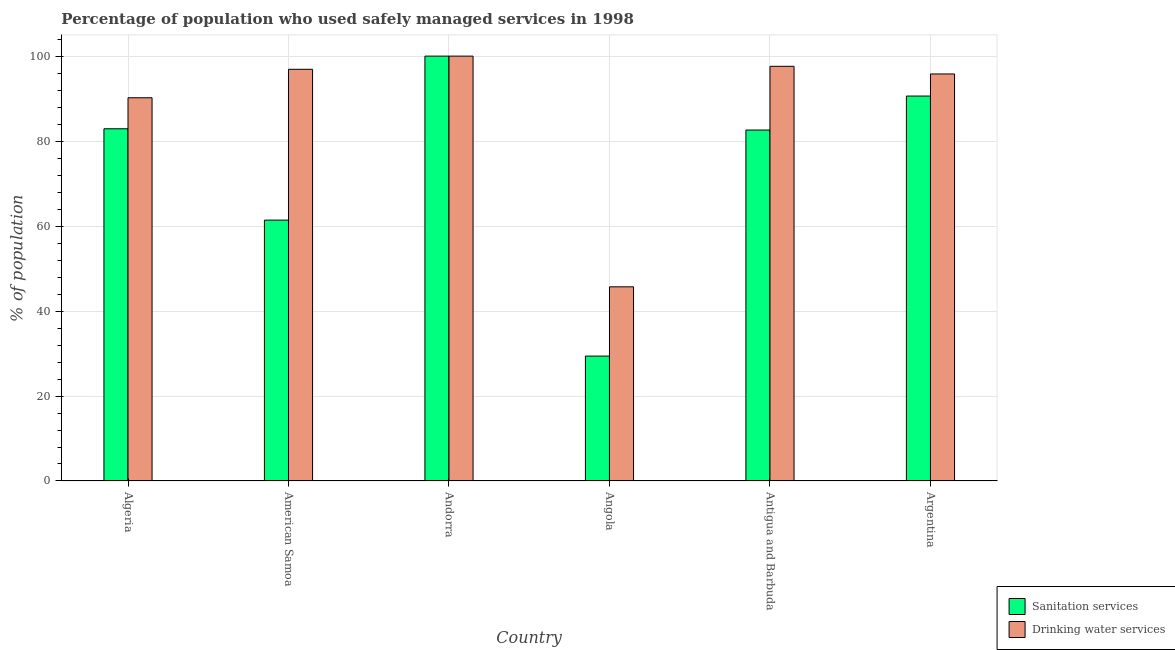Are the number of bars on each tick of the X-axis equal?
Offer a very short reply. Yes. How many bars are there on the 1st tick from the left?
Ensure brevity in your answer.  2. How many bars are there on the 5th tick from the right?
Keep it short and to the point. 2. What is the label of the 1st group of bars from the left?
Your response must be concise. Algeria. In how many cases, is the number of bars for a given country not equal to the number of legend labels?
Ensure brevity in your answer.  0. What is the percentage of population who used drinking water services in Angola?
Provide a succinct answer. 45.7. Across all countries, what is the maximum percentage of population who used drinking water services?
Give a very brief answer. 100. Across all countries, what is the minimum percentage of population who used drinking water services?
Make the answer very short. 45.7. In which country was the percentage of population who used sanitation services maximum?
Give a very brief answer. Andorra. In which country was the percentage of population who used drinking water services minimum?
Your answer should be very brief. Angola. What is the total percentage of population who used sanitation services in the graph?
Your response must be concise. 446.9. What is the difference between the percentage of population who used sanitation services in Algeria and that in American Samoa?
Your answer should be very brief. 21.5. What is the difference between the percentage of population who used sanitation services in Antigua and Barbuda and the percentage of population who used drinking water services in Andorra?
Provide a succinct answer. -17.4. What is the average percentage of population who used sanitation services per country?
Provide a short and direct response. 74.48. What is the difference between the percentage of population who used sanitation services and percentage of population who used drinking water services in Angola?
Offer a terse response. -16.3. What is the ratio of the percentage of population who used drinking water services in American Samoa to that in Antigua and Barbuda?
Ensure brevity in your answer.  0.99. Is the percentage of population who used drinking water services in Antigua and Barbuda less than that in Argentina?
Your answer should be very brief. No. What is the difference between the highest and the second highest percentage of population who used sanitation services?
Offer a terse response. 9.4. What is the difference between the highest and the lowest percentage of population who used drinking water services?
Provide a succinct answer. 54.3. In how many countries, is the percentage of population who used drinking water services greater than the average percentage of population who used drinking water services taken over all countries?
Ensure brevity in your answer.  5. Is the sum of the percentage of population who used drinking water services in Antigua and Barbuda and Argentina greater than the maximum percentage of population who used sanitation services across all countries?
Your answer should be very brief. Yes. What does the 1st bar from the left in Andorra represents?
Your answer should be very brief. Sanitation services. What does the 2nd bar from the right in American Samoa represents?
Your response must be concise. Sanitation services. Are all the bars in the graph horizontal?
Offer a very short reply. No. How many countries are there in the graph?
Ensure brevity in your answer.  6. What is the difference between two consecutive major ticks on the Y-axis?
Your answer should be compact. 20. How many legend labels are there?
Offer a very short reply. 2. How are the legend labels stacked?
Offer a terse response. Vertical. What is the title of the graph?
Provide a succinct answer. Percentage of population who used safely managed services in 1998. What is the label or title of the Y-axis?
Offer a terse response. % of population. What is the % of population of Sanitation services in Algeria?
Make the answer very short. 82.9. What is the % of population in Drinking water services in Algeria?
Your response must be concise. 90.2. What is the % of population of Sanitation services in American Samoa?
Your response must be concise. 61.4. What is the % of population of Drinking water services in American Samoa?
Offer a terse response. 96.9. What is the % of population in Sanitation services in Angola?
Your response must be concise. 29.4. What is the % of population of Drinking water services in Angola?
Your answer should be very brief. 45.7. What is the % of population of Sanitation services in Antigua and Barbuda?
Make the answer very short. 82.6. What is the % of population of Drinking water services in Antigua and Barbuda?
Keep it short and to the point. 97.6. What is the % of population of Sanitation services in Argentina?
Offer a very short reply. 90.6. What is the % of population of Drinking water services in Argentina?
Provide a short and direct response. 95.8. Across all countries, what is the maximum % of population in Drinking water services?
Keep it short and to the point. 100. Across all countries, what is the minimum % of population in Sanitation services?
Your answer should be very brief. 29.4. Across all countries, what is the minimum % of population in Drinking water services?
Give a very brief answer. 45.7. What is the total % of population in Sanitation services in the graph?
Give a very brief answer. 446.9. What is the total % of population in Drinking water services in the graph?
Keep it short and to the point. 526.2. What is the difference between the % of population of Sanitation services in Algeria and that in American Samoa?
Provide a succinct answer. 21.5. What is the difference between the % of population of Drinking water services in Algeria and that in American Samoa?
Make the answer very short. -6.7. What is the difference between the % of population of Sanitation services in Algeria and that in Andorra?
Keep it short and to the point. -17.1. What is the difference between the % of population of Drinking water services in Algeria and that in Andorra?
Your answer should be compact. -9.8. What is the difference between the % of population in Sanitation services in Algeria and that in Angola?
Your answer should be compact. 53.5. What is the difference between the % of population of Drinking water services in Algeria and that in Angola?
Provide a short and direct response. 44.5. What is the difference between the % of population of Sanitation services in Algeria and that in Antigua and Barbuda?
Provide a succinct answer. 0.3. What is the difference between the % of population in Sanitation services in American Samoa and that in Andorra?
Provide a short and direct response. -38.6. What is the difference between the % of population in Sanitation services in American Samoa and that in Angola?
Provide a succinct answer. 32. What is the difference between the % of population of Drinking water services in American Samoa and that in Angola?
Your answer should be very brief. 51.2. What is the difference between the % of population in Sanitation services in American Samoa and that in Antigua and Barbuda?
Give a very brief answer. -21.2. What is the difference between the % of population in Drinking water services in American Samoa and that in Antigua and Barbuda?
Your answer should be compact. -0.7. What is the difference between the % of population of Sanitation services in American Samoa and that in Argentina?
Ensure brevity in your answer.  -29.2. What is the difference between the % of population of Sanitation services in Andorra and that in Angola?
Your answer should be compact. 70.6. What is the difference between the % of population of Drinking water services in Andorra and that in Angola?
Provide a short and direct response. 54.3. What is the difference between the % of population of Drinking water services in Andorra and that in Antigua and Barbuda?
Provide a short and direct response. 2.4. What is the difference between the % of population in Sanitation services in Andorra and that in Argentina?
Keep it short and to the point. 9.4. What is the difference between the % of population of Sanitation services in Angola and that in Antigua and Barbuda?
Ensure brevity in your answer.  -53.2. What is the difference between the % of population of Drinking water services in Angola and that in Antigua and Barbuda?
Make the answer very short. -51.9. What is the difference between the % of population of Sanitation services in Angola and that in Argentina?
Keep it short and to the point. -61.2. What is the difference between the % of population of Drinking water services in Angola and that in Argentina?
Make the answer very short. -50.1. What is the difference between the % of population in Sanitation services in Antigua and Barbuda and that in Argentina?
Ensure brevity in your answer.  -8. What is the difference between the % of population in Sanitation services in Algeria and the % of population in Drinking water services in Andorra?
Offer a very short reply. -17.1. What is the difference between the % of population of Sanitation services in Algeria and the % of population of Drinking water services in Angola?
Ensure brevity in your answer.  37.2. What is the difference between the % of population of Sanitation services in Algeria and the % of population of Drinking water services in Antigua and Barbuda?
Your response must be concise. -14.7. What is the difference between the % of population of Sanitation services in Algeria and the % of population of Drinking water services in Argentina?
Give a very brief answer. -12.9. What is the difference between the % of population in Sanitation services in American Samoa and the % of population in Drinking water services in Andorra?
Keep it short and to the point. -38.6. What is the difference between the % of population of Sanitation services in American Samoa and the % of population of Drinking water services in Angola?
Offer a terse response. 15.7. What is the difference between the % of population of Sanitation services in American Samoa and the % of population of Drinking water services in Antigua and Barbuda?
Make the answer very short. -36.2. What is the difference between the % of population in Sanitation services in American Samoa and the % of population in Drinking water services in Argentina?
Make the answer very short. -34.4. What is the difference between the % of population in Sanitation services in Andorra and the % of population in Drinking water services in Angola?
Offer a terse response. 54.3. What is the difference between the % of population in Sanitation services in Andorra and the % of population in Drinking water services in Antigua and Barbuda?
Offer a very short reply. 2.4. What is the difference between the % of population of Sanitation services in Andorra and the % of population of Drinking water services in Argentina?
Your answer should be very brief. 4.2. What is the difference between the % of population in Sanitation services in Angola and the % of population in Drinking water services in Antigua and Barbuda?
Provide a succinct answer. -68.2. What is the difference between the % of population of Sanitation services in Angola and the % of population of Drinking water services in Argentina?
Your response must be concise. -66.4. What is the average % of population in Sanitation services per country?
Provide a succinct answer. 74.48. What is the average % of population of Drinking water services per country?
Your answer should be compact. 87.7. What is the difference between the % of population of Sanitation services and % of population of Drinking water services in Algeria?
Make the answer very short. -7.3. What is the difference between the % of population of Sanitation services and % of population of Drinking water services in American Samoa?
Your answer should be compact. -35.5. What is the difference between the % of population in Sanitation services and % of population in Drinking water services in Angola?
Ensure brevity in your answer.  -16.3. What is the difference between the % of population of Sanitation services and % of population of Drinking water services in Argentina?
Offer a terse response. -5.2. What is the ratio of the % of population in Sanitation services in Algeria to that in American Samoa?
Ensure brevity in your answer.  1.35. What is the ratio of the % of population of Drinking water services in Algeria to that in American Samoa?
Your answer should be very brief. 0.93. What is the ratio of the % of population in Sanitation services in Algeria to that in Andorra?
Your response must be concise. 0.83. What is the ratio of the % of population of Drinking water services in Algeria to that in Andorra?
Offer a terse response. 0.9. What is the ratio of the % of population of Sanitation services in Algeria to that in Angola?
Provide a succinct answer. 2.82. What is the ratio of the % of population of Drinking water services in Algeria to that in Angola?
Your answer should be compact. 1.97. What is the ratio of the % of population of Sanitation services in Algeria to that in Antigua and Barbuda?
Provide a succinct answer. 1. What is the ratio of the % of population of Drinking water services in Algeria to that in Antigua and Barbuda?
Give a very brief answer. 0.92. What is the ratio of the % of population of Sanitation services in Algeria to that in Argentina?
Keep it short and to the point. 0.92. What is the ratio of the % of population of Drinking water services in Algeria to that in Argentina?
Your answer should be very brief. 0.94. What is the ratio of the % of population in Sanitation services in American Samoa to that in Andorra?
Provide a succinct answer. 0.61. What is the ratio of the % of population in Drinking water services in American Samoa to that in Andorra?
Keep it short and to the point. 0.97. What is the ratio of the % of population in Sanitation services in American Samoa to that in Angola?
Your answer should be very brief. 2.09. What is the ratio of the % of population in Drinking water services in American Samoa to that in Angola?
Your answer should be very brief. 2.12. What is the ratio of the % of population in Sanitation services in American Samoa to that in Antigua and Barbuda?
Offer a terse response. 0.74. What is the ratio of the % of population of Sanitation services in American Samoa to that in Argentina?
Make the answer very short. 0.68. What is the ratio of the % of population of Drinking water services in American Samoa to that in Argentina?
Make the answer very short. 1.01. What is the ratio of the % of population in Sanitation services in Andorra to that in Angola?
Your response must be concise. 3.4. What is the ratio of the % of population of Drinking water services in Andorra to that in Angola?
Give a very brief answer. 2.19. What is the ratio of the % of population in Sanitation services in Andorra to that in Antigua and Barbuda?
Keep it short and to the point. 1.21. What is the ratio of the % of population of Drinking water services in Andorra to that in Antigua and Barbuda?
Give a very brief answer. 1.02. What is the ratio of the % of population of Sanitation services in Andorra to that in Argentina?
Give a very brief answer. 1.1. What is the ratio of the % of population in Drinking water services in Andorra to that in Argentina?
Give a very brief answer. 1.04. What is the ratio of the % of population in Sanitation services in Angola to that in Antigua and Barbuda?
Offer a terse response. 0.36. What is the ratio of the % of population of Drinking water services in Angola to that in Antigua and Barbuda?
Keep it short and to the point. 0.47. What is the ratio of the % of population of Sanitation services in Angola to that in Argentina?
Offer a very short reply. 0.32. What is the ratio of the % of population in Drinking water services in Angola to that in Argentina?
Offer a very short reply. 0.48. What is the ratio of the % of population of Sanitation services in Antigua and Barbuda to that in Argentina?
Ensure brevity in your answer.  0.91. What is the ratio of the % of population of Drinking water services in Antigua and Barbuda to that in Argentina?
Your answer should be compact. 1.02. What is the difference between the highest and the second highest % of population in Drinking water services?
Keep it short and to the point. 2.4. What is the difference between the highest and the lowest % of population in Sanitation services?
Provide a short and direct response. 70.6. What is the difference between the highest and the lowest % of population in Drinking water services?
Make the answer very short. 54.3. 